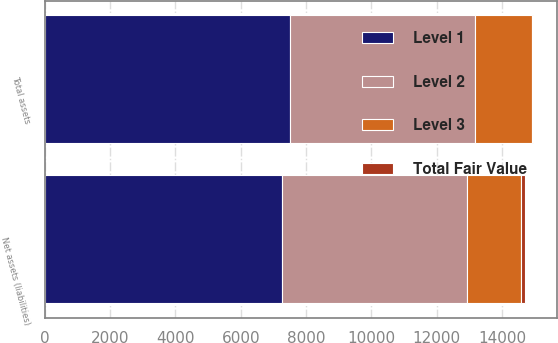Convert chart. <chart><loc_0><loc_0><loc_500><loc_500><stacked_bar_chart><ecel><fcel>Total assets<fcel>Net assets (liabilities)<nl><fcel>Level 1<fcel>7503<fcel>7273<nl><fcel>Level 2<fcel>5658<fcel>5656<nl><fcel>Level 3<fcel>1743<fcel>1657<nl><fcel>Total Fair Value<fcel>28<fcel>114<nl></chart> 